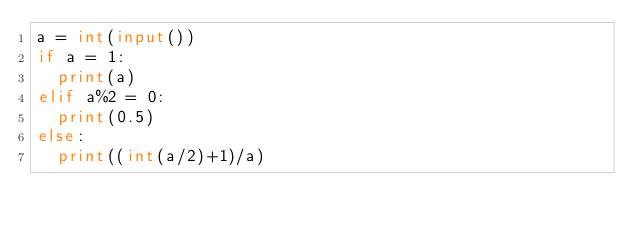<code> <loc_0><loc_0><loc_500><loc_500><_Python_>a = int(input())
if a = 1:
  print(a)
elif a%2 = 0:
  print(0.5)
else:
  print((int(a/2)+1)/a)
</code> 